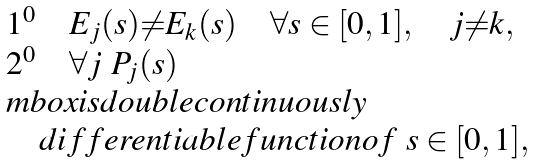<formula> <loc_0><loc_0><loc_500><loc_500>\begin{array} { l } { { 1 ^ { 0 } \quad E _ { j } ( s ) { \neq } E _ { k } ( s ) \quad \forall s \in [ 0 , 1 ] , \quad j { \neq } k , } } \\ { { 2 ^ { 0 } \quad \forall j \ P _ { j } ( s ) } } \\ { { m b o x { i s d o u b l e c o n t i n u o u s l y } } } \\ { \quad d i f f e r e n t i a b l e f u n c t i o n o f \ s \in [ 0 , 1 ] , } \end{array}</formula> 